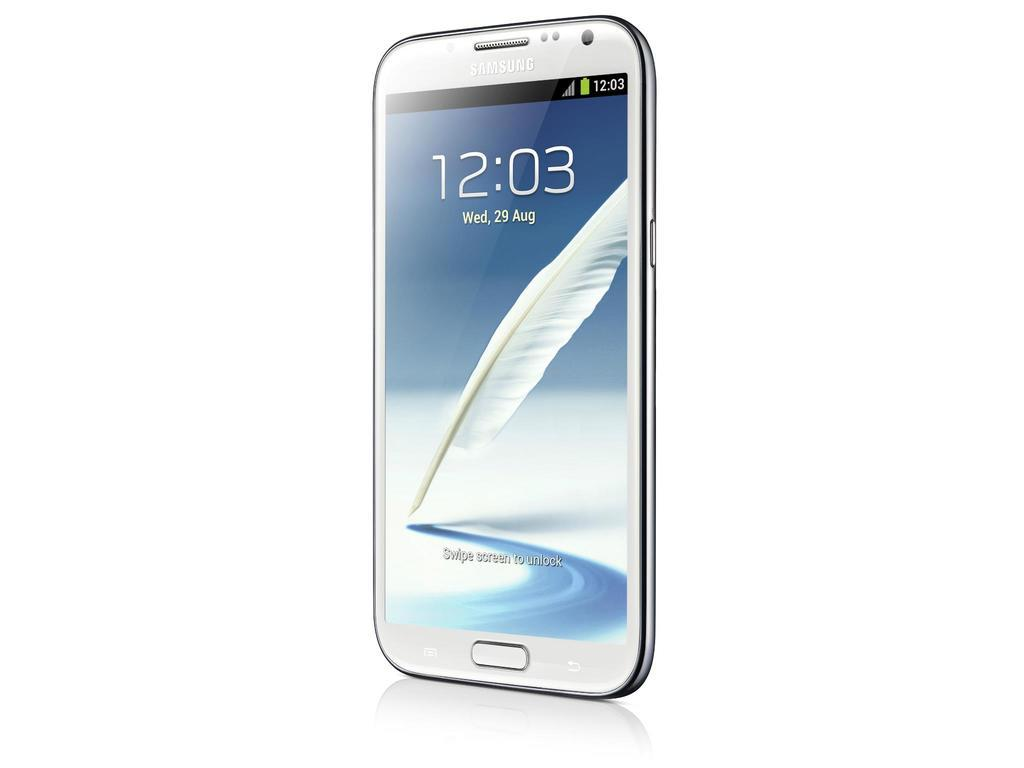<image>
Provide a brief description of the given image. A cell phone shows the time "12:03" and the day "Wed, 29 Aug" on the screen. 